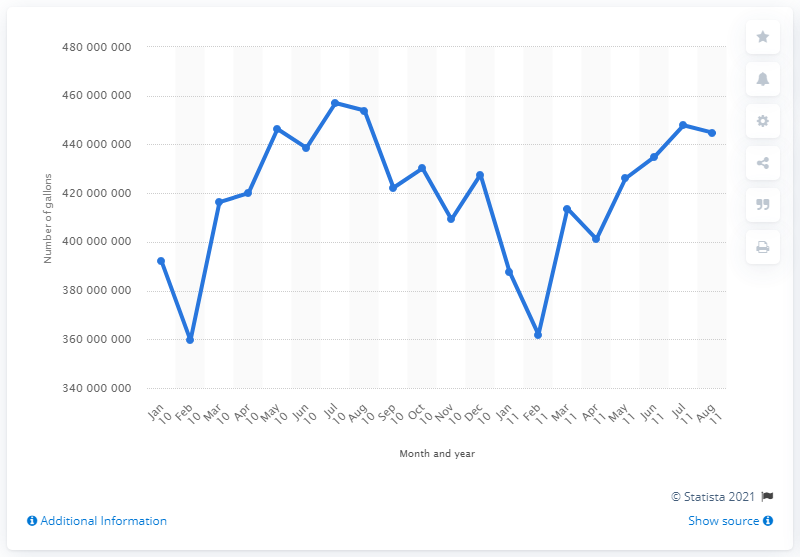Draw attention to some important aspects in this diagram. In January 2011, a total of 38,778,265.8 gallons of gasoline were sold. In January 2010, a total of 392,104,432 gallons of gasoline were sold in the state of Ohio. 